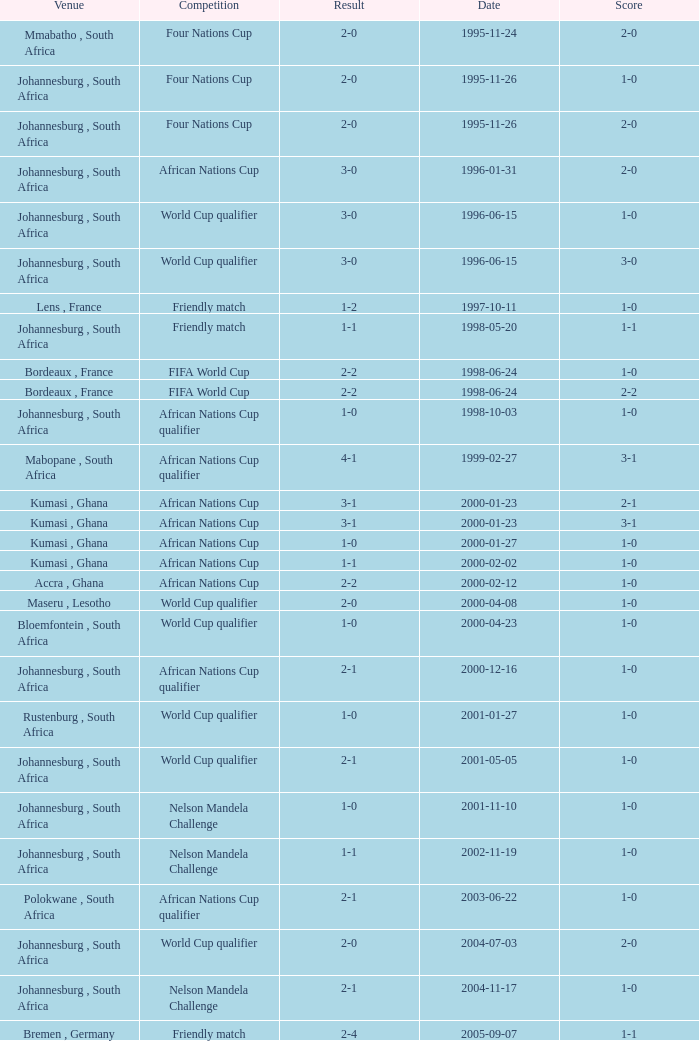What is the Date of the Fifa World Cup with a Score of 1-0? 1998-06-24. 